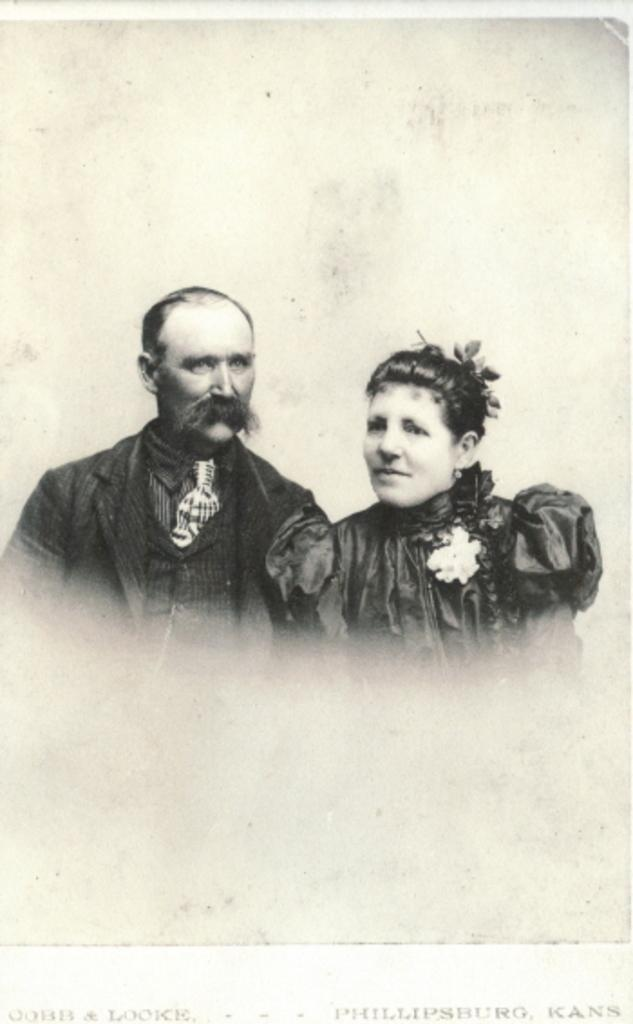What is the main subject of the image? There is a picture in the image. What can be seen in the picture? There is a man and a woman in the picture. What type of rifle is the man holding in the picture? There is no rifle present in the picture; it only features a man and a woman. What type of chess piece is the woman holding in the picture? There is no chess piece present in the picture; it only features a man and a woman. 